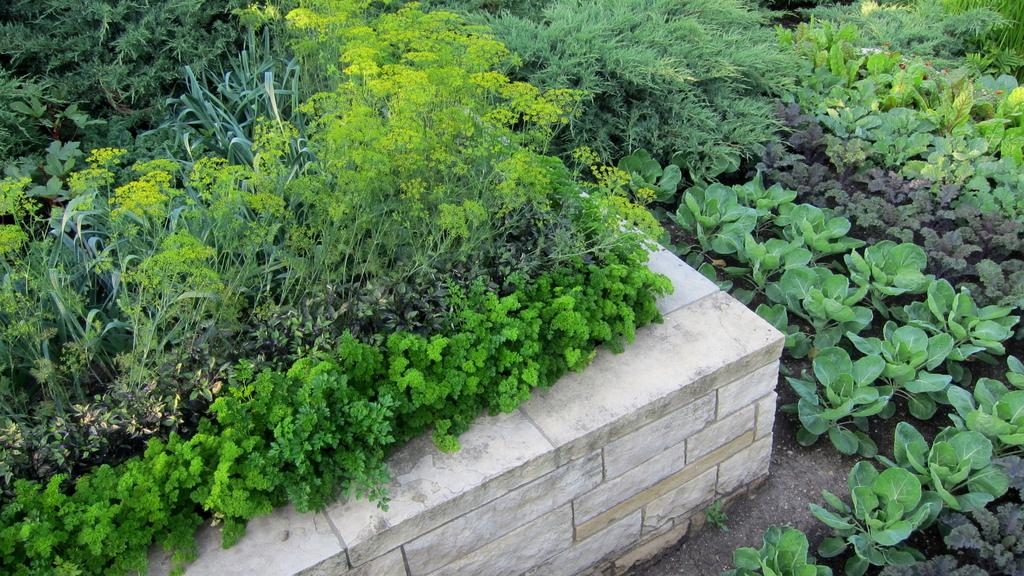What type of living organisms can be seen in the image? Plants can be seen in the image. What type of tent is visible in the image? There is no tent present in the image; it only features plants. How does the daughter interact with the plants in the image? There is no daughter present in the image, only plants. 